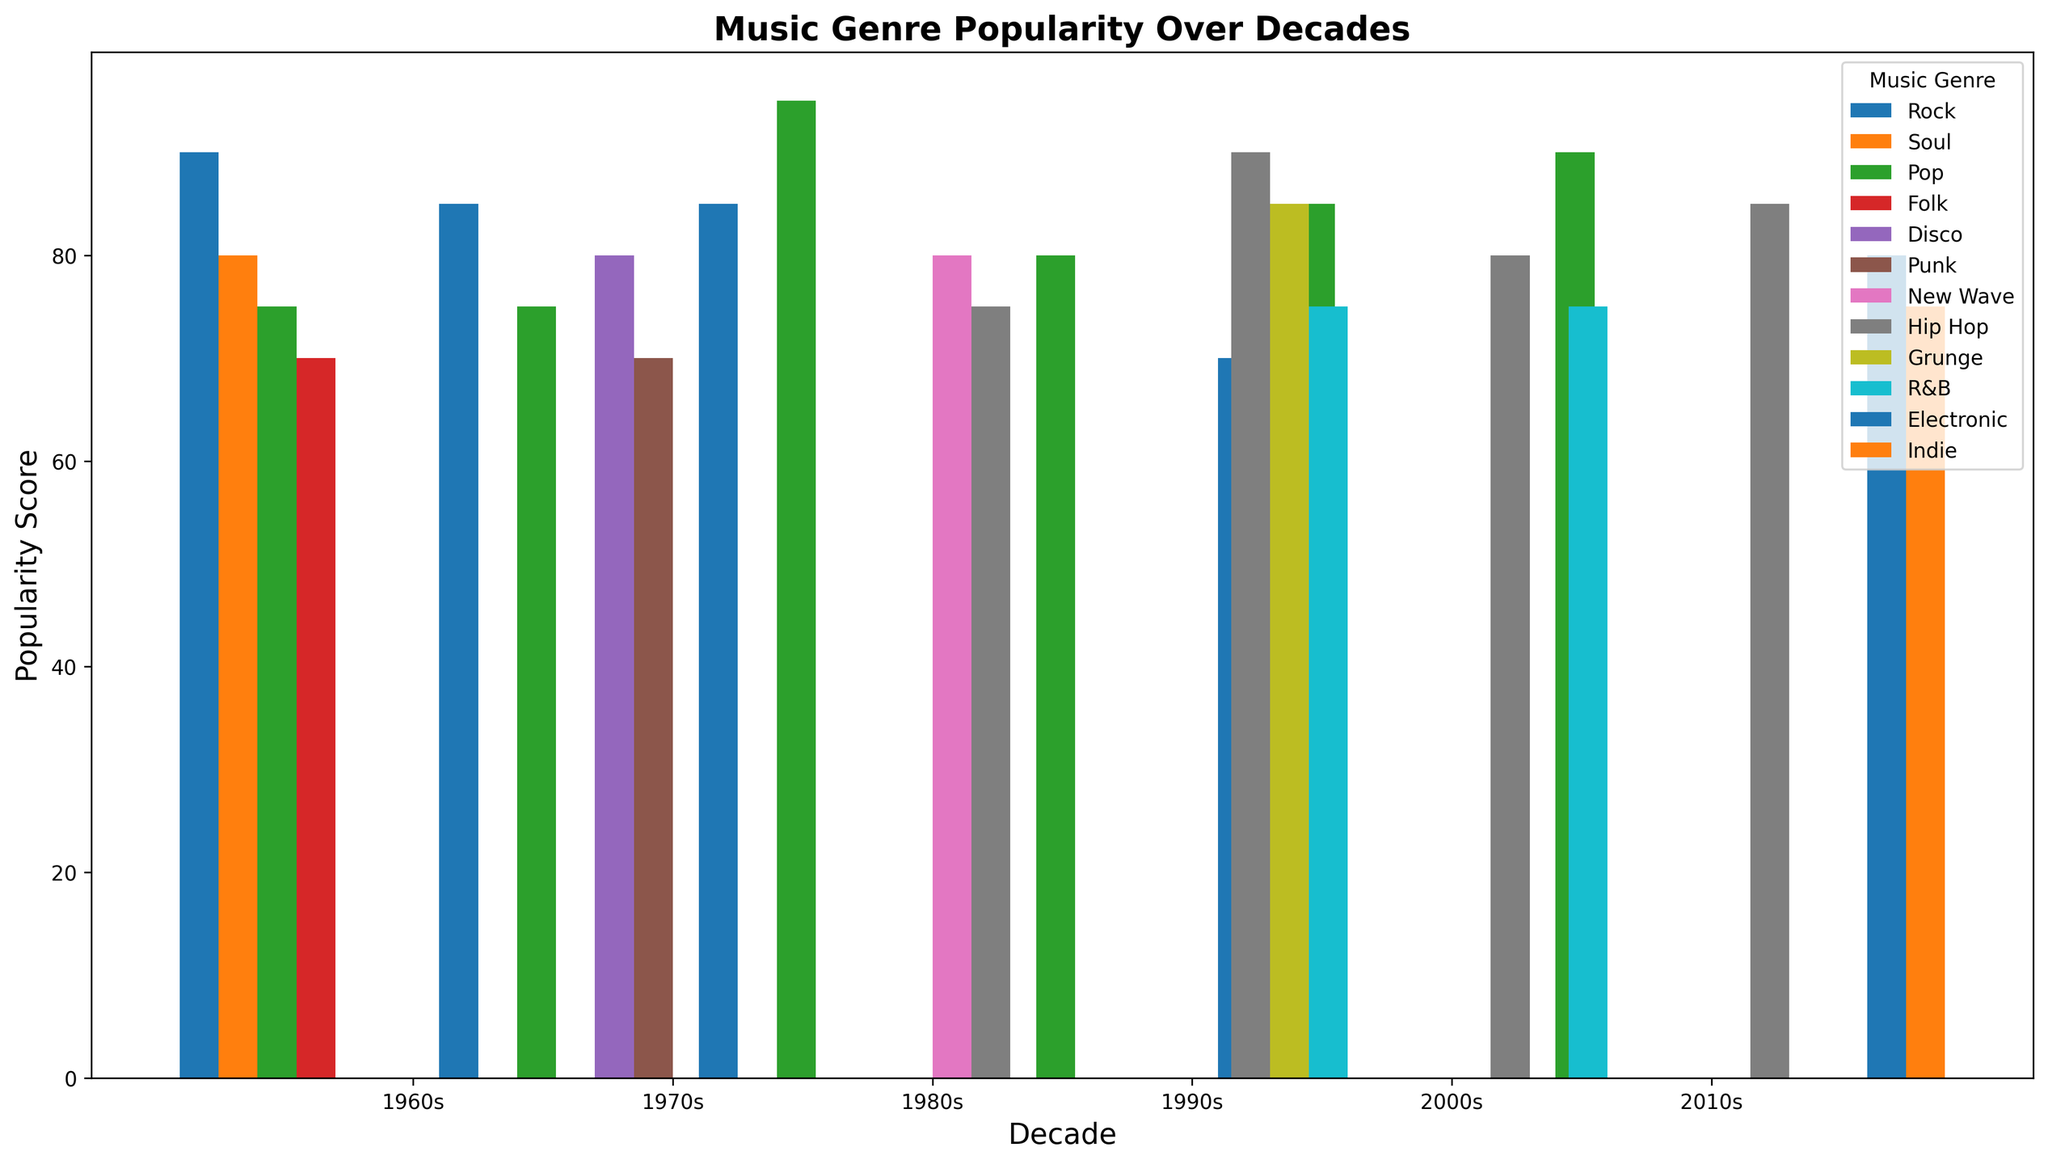Which music genre had the highest popularity score in the 1980s? From the plot, locate the 1980s on the x-axis and identify the tallest bar for that decade. The tallest bar represents the genre with the highest popularity score.
Answer: Pop How does the popularity of Rock compare between the 1960s and the 2000s? Find the bars representing Rock in the 1960s and the 2000s. Observe their heights and compare their values to determine which decade has a higher score.
Answer: Higher in the 1960s Which decade saw the highest popularity score for Hip Hop? Identify the bars representing Hip Hop in each decade. Compare the heights of these bars to determine which one is the tallest.
Answer: 1990s What is the total popularity score of Pop music across all decades? Sum the heights of the bars representing Pop music in each decade. Add 75 (1960s) + 75 (1970s) + 95 (1980s) + 80 (1990s) + 85 (2000s) + 90 (2010s).
Answer: 500 In the 2010s, which genre had the lowest popularity score? Locate the 2010s on the x-axis and find the shortest bar for that decade. This bar represents the genre with the lowest popularity score.
Answer: Indie On average, which genre scored the highest popularity across all the decades? Calculate the average score for each genre by summing their scores across decades and dividing by the number of decades they appeared. Compare these averages to determine the highest one.
Answer: Pop Which genre showed the largest increase in popularity from one decade to the next, and in which decades did this change occur? Identify the bars that grow the most between consecutive decades. Calculate the change for each genre and identify the largest increase.
Answer: Pop from 1970s to 1980s Compare the popularity scores of Aretha Franklin and Beyoncé. Who had a higher score and by how much? Find the bar for Aretha Franklin (1960s, Soul) and Beyoncé (2000s, R&B). Subtract the lower score from the higher score to find the difference.
Answer: Aretha Franklin by 5 Considering new genres that appear from one decade to the next, which decade introduced the most new genres? Check each decade and count the number of new genres that appear for the first time compared to the previous decade. Identify the decade with the highest count of new genres.
Answer: 1980s 